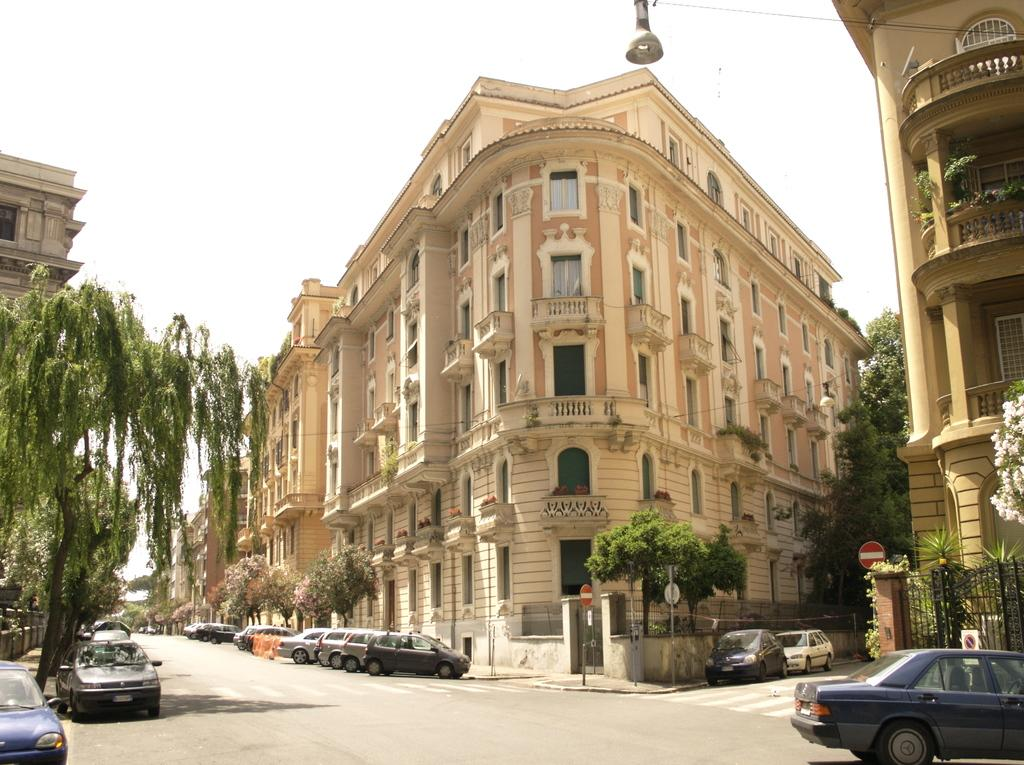What type of structures can be seen in the image? There are buildings in the image. What architectural features are visible on the buildings? There are windows visible on the buildings. What type of vegetation is present in the image? There are trees in the image. What type of signage can be seen in the image? There are signboards in the image. What type of vertical structures are present in the image? There are poles in the image. What type of barrier is present in the image? There is fencing in the image. What type of transportation is visible in the image? There are vehicles on the road in the image. What is the color of the sky in the image? The sky is white in color. Can you tell me how many cups of juice are on the table in the image? There is no table or cups of juice present in the image. What type of parent is shown interacting with the children in the image? There are no children or parents present in the image. 